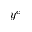Convert formula to latex. <formula><loc_0><loc_0><loc_500><loc_500>y ^ { c }</formula> 